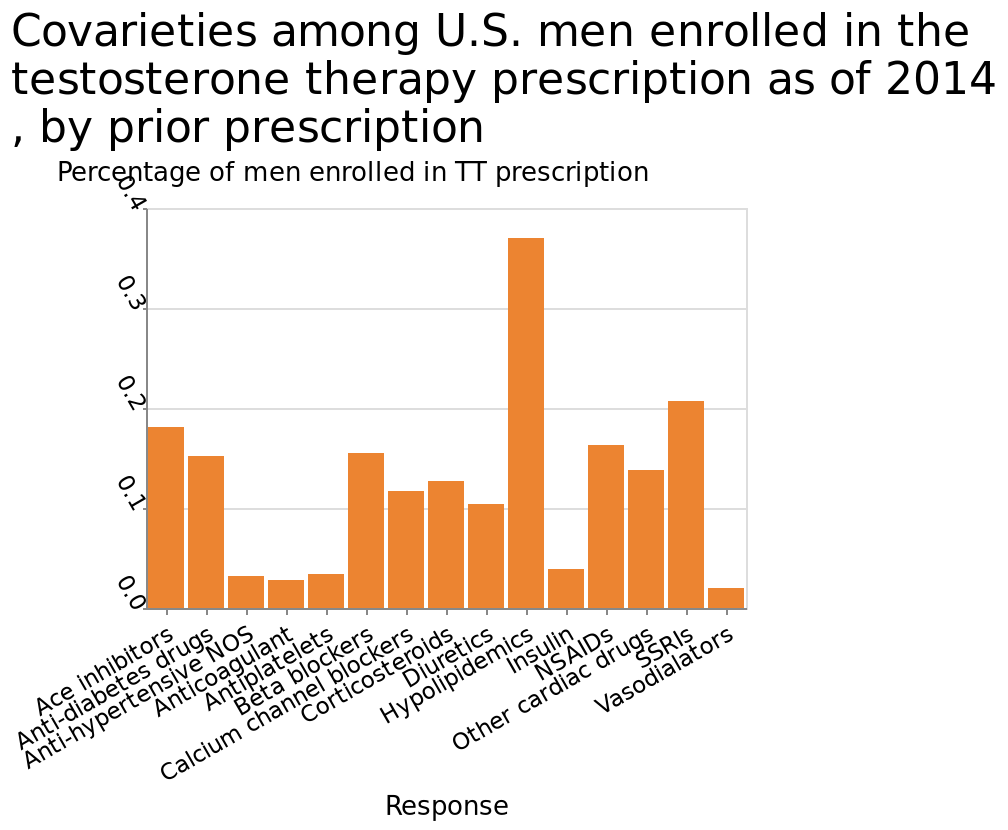<image>
According to the chart, which category stands out as the biggest?  Hypolipidemics. 